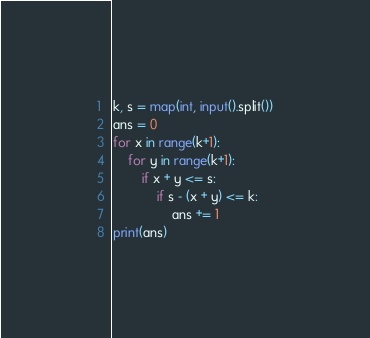Convert code to text. <code><loc_0><loc_0><loc_500><loc_500><_Python_>k, s = map(int, input().split())
ans = 0
for x in range(k+1):
    for y in range(k+1):
        if x + y <= s:
            if s - (x + y) <= k:
                ans += 1
print(ans)</code> 